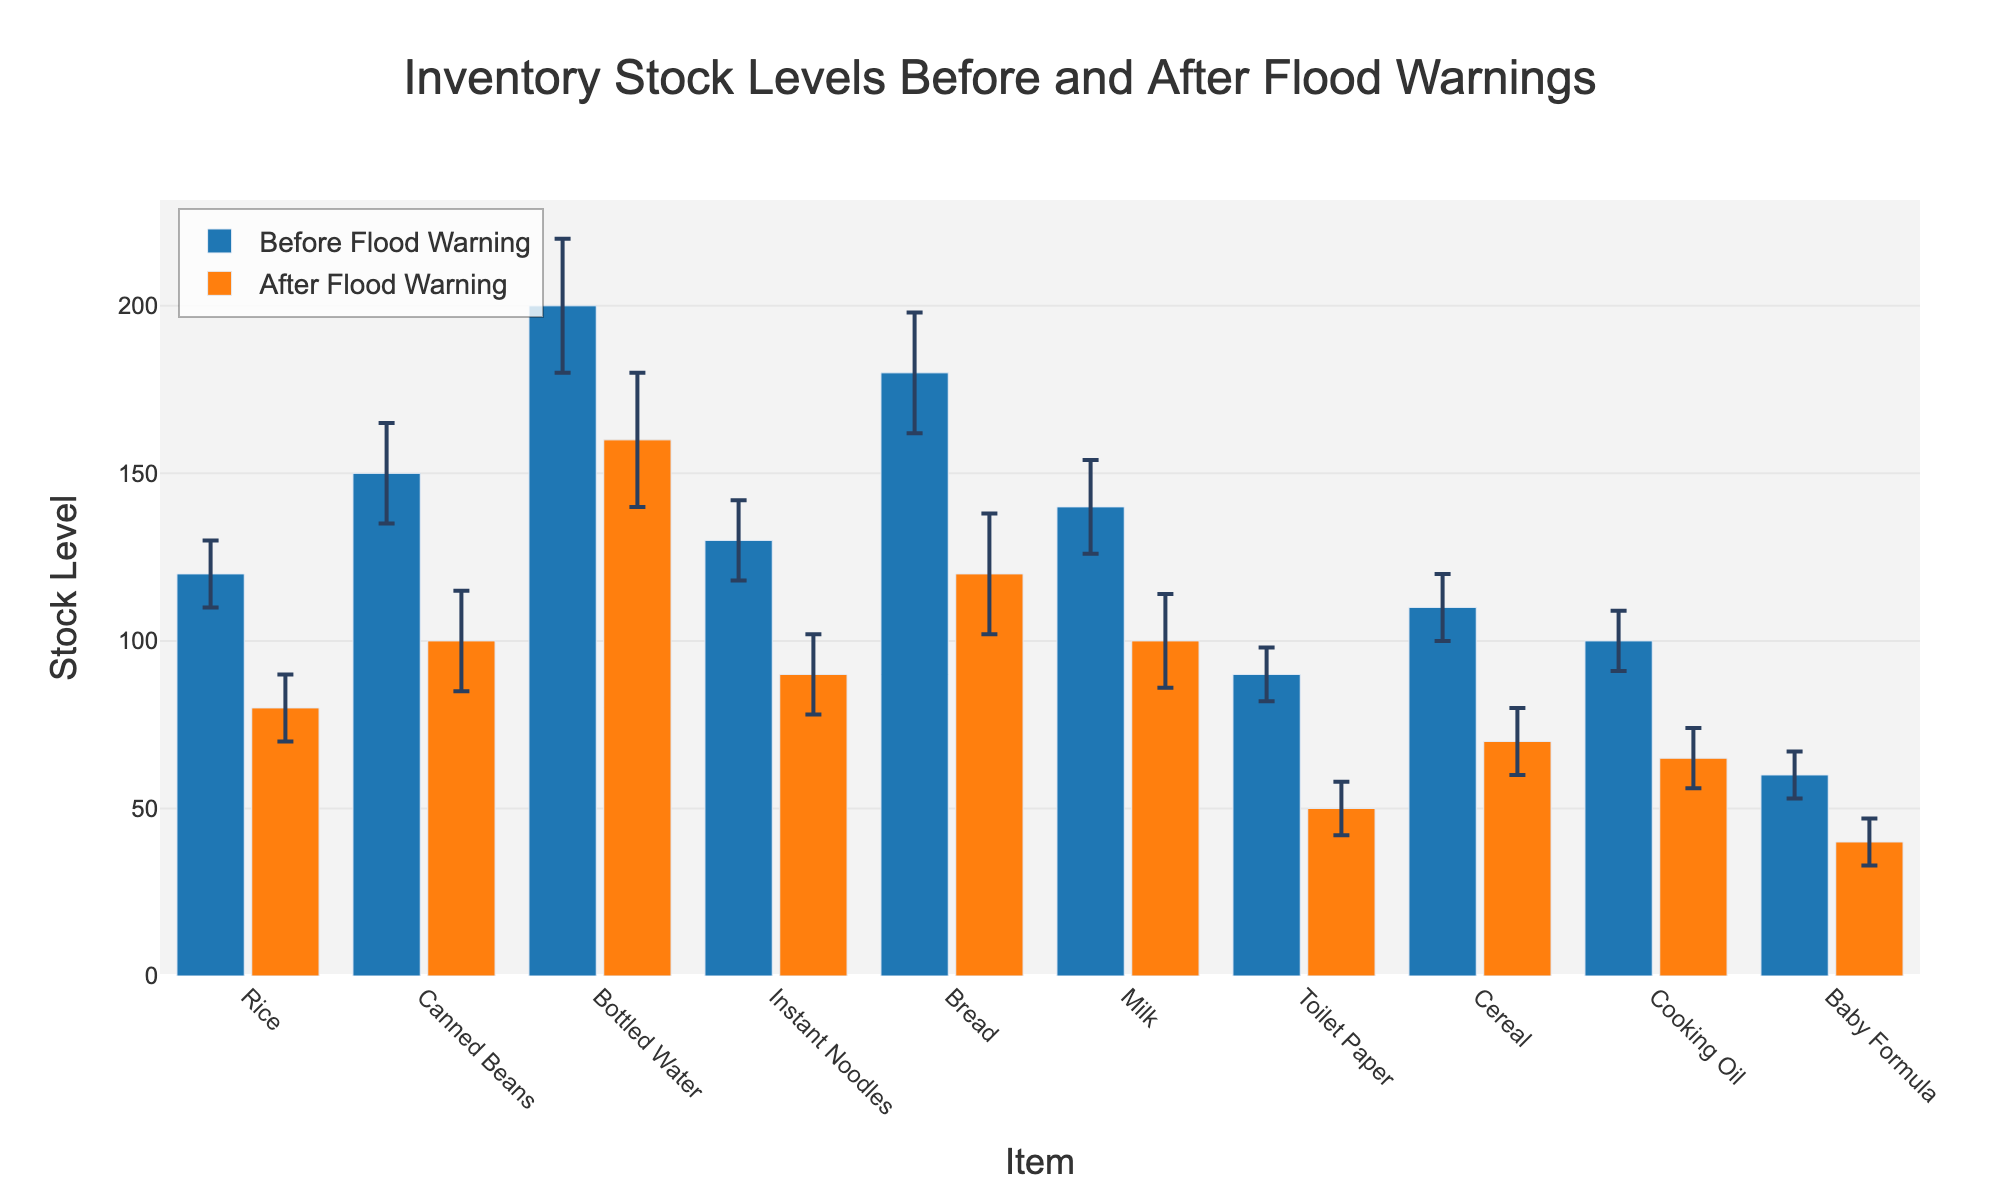How many different items are shown in the figure? The x-axis lists all the items, and each unique item corresponds to a bar pair. By counting the unique items on the x-axis, we can determine the total number.
Answer: 10 What are the colors used to represent the stock levels before and after the flood warning? The legend in the figure displays the colors used to represent different time frames. "Before Flood Warning" is shown in blue, and "After Flood Warning" is shown in orange.
Answer: Blue and Orange Which item shows the largest drop in stock level after the flood warning? By visually examining the lengths of the bars for each item, the item with the greatest difference between the "Before" and "After" bars indicates the largest drop. Bottled Water shows the largest drop, decreasing from 200 to 160.
Answer: Bottled Water What is the stock level of Bread before and after the flood warning? Locate the "Bread" bars on the x-axis and observe their respective heights. Bread has a stock level of 180 before the Flood Warning and 120 after.
Answer: 180 before, 120 after How much did the stock level of Milk decrease after the flood warning? Subtract the stock level of Milk after the flood warning (100) from the stock level before the flood warning (140).
Answer: 40 Which item has the smallest stock level after the flood warning? Locate the shortest "After Flood Warning" bar, which represents Baby Formula, with a stock level of 40.
Answer: Baby Formula What is the error margin for Toilet Paper’s stock level before the flood warning? Find Toilet Paper on the x-axis and look at the error bar height for the "Before Flood Warning" bar. The error margin is 8 units.
Answer: 8 What is the average stock level of Rice before and after the flood warning? The stock level is 120 before and 80 after. The average is calculated as (120 + 80) / 2.
Answer: 100 Which item has the smallest error margin? By checking each item's error bars, Baby Formula has the smallest error margin of 7 units.
Answer: Baby Formula What is the total stock level of canned goods (Canned Beans and Instant Noodles) after the flood warning? Sum the stock levels of Canned Beans (100) and Instant Noodles (90) after the flood warning; 100 + 90.
Answer: 190 